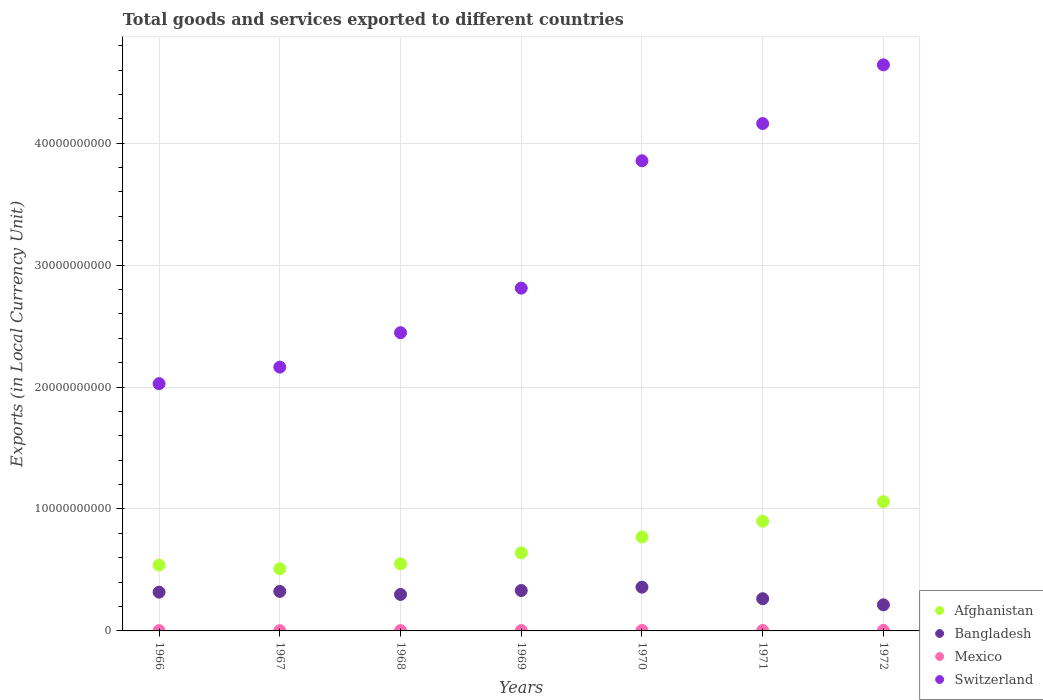How many different coloured dotlines are there?
Make the answer very short. 4. What is the Amount of goods and services exports in Afghanistan in 1971?
Keep it short and to the point. 9.00e+09. Across all years, what is the maximum Amount of goods and services exports in Switzerland?
Make the answer very short. 4.64e+1. Across all years, what is the minimum Amount of goods and services exports in Bangladesh?
Your answer should be very brief. 2.14e+09. In which year was the Amount of goods and services exports in Afghanistan maximum?
Offer a terse response. 1972. In which year was the Amount of goods and services exports in Afghanistan minimum?
Your answer should be compact. 1967. What is the total Amount of goods and services exports in Afghanistan in the graph?
Ensure brevity in your answer.  4.97e+1. What is the difference between the Amount of goods and services exports in Bangladesh in 1970 and that in 1971?
Ensure brevity in your answer.  9.45e+08. What is the difference between the Amount of goods and services exports in Bangladesh in 1969 and the Amount of goods and services exports in Mexico in 1970?
Your response must be concise. 3.28e+09. What is the average Amount of goods and services exports in Afghanistan per year?
Make the answer very short. 7.10e+09. In the year 1967, what is the difference between the Amount of goods and services exports in Switzerland and Amount of goods and services exports in Bangladesh?
Your answer should be very brief. 1.84e+1. What is the ratio of the Amount of goods and services exports in Mexico in 1967 to that in 1968?
Give a very brief answer. 0.88. What is the difference between the highest and the second highest Amount of goods and services exports in Switzerland?
Provide a succinct answer. 4.81e+09. What is the difference between the highest and the lowest Amount of goods and services exports in Afghanistan?
Make the answer very short. 5.50e+09. Is the sum of the Amount of goods and services exports in Bangladesh in 1968 and 1970 greater than the maximum Amount of goods and services exports in Mexico across all years?
Your answer should be very brief. Yes. Is it the case that in every year, the sum of the Amount of goods and services exports in Mexico and Amount of goods and services exports in Bangladesh  is greater than the sum of Amount of goods and services exports in Switzerland and Amount of goods and services exports in Afghanistan?
Give a very brief answer. No. Is the Amount of goods and services exports in Bangladesh strictly greater than the Amount of goods and services exports in Mexico over the years?
Your answer should be compact. Yes. How many dotlines are there?
Make the answer very short. 4. How many years are there in the graph?
Your response must be concise. 7. What is the difference between two consecutive major ticks on the Y-axis?
Give a very brief answer. 1.00e+1. Does the graph contain any zero values?
Your answer should be very brief. No. What is the title of the graph?
Give a very brief answer. Total goods and services exported to different countries. Does "Russian Federation" appear as one of the legend labels in the graph?
Ensure brevity in your answer.  No. What is the label or title of the Y-axis?
Your answer should be compact. Exports (in Local Currency Unit). What is the Exports (in Local Currency Unit) in Afghanistan in 1966?
Your answer should be very brief. 5.40e+09. What is the Exports (in Local Currency Unit) of Bangladesh in 1966?
Make the answer very short. 3.18e+09. What is the Exports (in Local Currency Unit) in Mexico in 1966?
Ensure brevity in your answer.  2.27e+07. What is the Exports (in Local Currency Unit) of Switzerland in 1966?
Offer a terse response. 2.03e+1. What is the Exports (in Local Currency Unit) of Afghanistan in 1967?
Offer a terse response. 5.10e+09. What is the Exports (in Local Currency Unit) in Bangladesh in 1967?
Ensure brevity in your answer.  3.24e+09. What is the Exports (in Local Currency Unit) of Mexico in 1967?
Offer a very short reply. 2.28e+07. What is the Exports (in Local Currency Unit) in Switzerland in 1967?
Offer a very short reply. 2.16e+1. What is the Exports (in Local Currency Unit) in Afghanistan in 1968?
Provide a succinct answer. 5.50e+09. What is the Exports (in Local Currency Unit) in Bangladesh in 1968?
Provide a succinct answer. 2.99e+09. What is the Exports (in Local Currency Unit) in Mexico in 1968?
Provide a short and direct response. 2.58e+07. What is the Exports (in Local Currency Unit) of Switzerland in 1968?
Provide a succinct answer. 2.45e+1. What is the Exports (in Local Currency Unit) in Afghanistan in 1969?
Keep it short and to the point. 6.40e+09. What is the Exports (in Local Currency Unit) of Bangladesh in 1969?
Give a very brief answer. 3.31e+09. What is the Exports (in Local Currency Unit) in Mexico in 1969?
Provide a succinct answer. 3.06e+07. What is the Exports (in Local Currency Unit) in Switzerland in 1969?
Make the answer very short. 2.81e+1. What is the Exports (in Local Currency Unit) in Afghanistan in 1970?
Make the answer very short. 7.70e+09. What is the Exports (in Local Currency Unit) in Bangladesh in 1970?
Provide a short and direct response. 3.59e+09. What is the Exports (in Local Currency Unit) of Mexico in 1970?
Your response must be concise. 3.44e+07. What is the Exports (in Local Currency Unit) of Switzerland in 1970?
Make the answer very short. 3.86e+1. What is the Exports (in Local Currency Unit) of Afghanistan in 1971?
Make the answer very short. 9.00e+09. What is the Exports (in Local Currency Unit) of Bangladesh in 1971?
Give a very brief answer. 2.64e+09. What is the Exports (in Local Currency Unit) of Mexico in 1971?
Ensure brevity in your answer.  3.74e+07. What is the Exports (in Local Currency Unit) in Switzerland in 1971?
Keep it short and to the point. 4.16e+1. What is the Exports (in Local Currency Unit) of Afghanistan in 1972?
Make the answer very short. 1.06e+1. What is the Exports (in Local Currency Unit) in Bangladesh in 1972?
Your answer should be compact. 2.14e+09. What is the Exports (in Local Currency Unit) of Mexico in 1972?
Keep it short and to the point. 4.55e+07. What is the Exports (in Local Currency Unit) in Switzerland in 1972?
Your answer should be compact. 4.64e+1. Across all years, what is the maximum Exports (in Local Currency Unit) in Afghanistan?
Provide a short and direct response. 1.06e+1. Across all years, what is the maximum Exports (in Local Currency Unit) of Bangladesh?
Offer a terse response. 3.59e+09. Across all years, what is the maximum Exports (in Local Currency Unit) in Mexico?
Your answer should be very brief. 4.55e+07. Across all years, what is the maximum Exports (in Local Currency Unit) in Switzerland?
Provide a short and direct response. 4.64e+1. Across all years, what is the minimum Exports (in Local Currency Unit) of Afghanistan?
Offer a very short reply. 5.10e+09. Across all years, what is the minimum Exports (in Local Currency Unit) of Bangladesh?
Offer a terse response. 2.14e+09. Across all years, what is the minimum Exports (in Local Currency Unit) of Mexico?
Make the answer very short. 2.27e+07. Across all years, what is the minimum Exports (in Local Currency Unit) of Switzerland?
Your response must be concise. 2.03e+1. What is the total Exports (in Local Currency Unit) of Afghanistan in the graph?
Your answer should be very brief. 4.97e+1. What is the total Exports (in Local Currency Unit) of Bangladesh in the graph?
Your response must be concise. 2.11e+1. What is the total Exports (in Local Currency Unit) in Mexico in the graph?
Provide a short and direct response. 2.19e+08. What is the total Exports (in Local Currency Unit) of Switzerland in the graph?
Make the answer very short. 2.21e+11. What is the difference between the Exports (in Local Currency Unit) of Afghanistan in 1966 and that in 1967?
Give a very brief answer. 3.00e+08. What is the difference between the Exports (in Local Currency Unit) of Bangladesh in 1966 and that in 1967?
Offer a terse response. -6.12e+07. What is the difference between the Exports (in Local Currency Unit) of Mexico in 1966 and that in 1967?
Your response must be concise. -8.90e+04. What is the difference between the Exports (in Local Currency Unit) of Switzerland in 1966 and that in 1967?
Provide a succinct answer. -1.36e+09. What is the difference between the Exports (in Local Currency Unit) of Afghanistan in 1966 and that in 1968?
Make the answer very short. -1.00e+08. What is the difference between the Exports (in Local Currency Unit) in Bangladesh in 1966 and that in 1968?
Your answer should be very brief. 1.86e+08. What is the difference between the Exports (in Local Currency Unit) in Mexico in 1966 and that in 1968?
Give a very brief answer. -3.12e+06. What is the difference between the Exports (in Local Currency Unit) of Switzerland in 1966 and that in 1968?
Keep it short and to the point. -4.18e+09. What is the difference between the Exports (in Local Currency Unit) in Afghanistan in 1966 and that in 1969?
Make the answer very short. -1.00e+09. What is the difference between the Exports (in Local Currency Unit) of Bangladesh in 1966 and that in 1969?
Make the answer very short. -1.33e+08. What is the difference between the Exports (in Local Currency Unit) of Mexico in 1966 and that in 1969?
Keep it short and to the point. -7.93e+06. What is the difference between the Exports (in Local Currency Unit) in Switzerland in 1966 and that in 1969?
Keep it short and to the point. -7.83e+09. What is the difference between the Exports (in Local Currency Unit) in Afghanistan in 1966 and that in 1970?
Make the answer very short. -2.30e+09. What is the difference between the Exports (in Local Currency Unit) of Bangladesh in 1966 and that in 1970?
Make the answer very short. -4.09e+08. What is the difference between the Exports (in Local Currency Unit) of Mexico in 1966 and that in 1970?
Your answer should be compact. -1.17e+07. What is the difference between the Exports (in Local Currency Unit) in Switzerland in 1966 and that in 1970?
Your answer should be compact. -1.83e+1. What is the difference between the Exports (in Local Currency Unit) of Afghanistan in 1966 and that in 1971?
Offer a terse response. -3.60e+09. What is the difference between the Exports (in Local Currency Unit) in Bangladesh in 1966 and that in 1971?
Your response must be concise. 5.36e+08. What is the difference between the Exports (in Local Currency Unit) of Mexico in 1966 and that in 1971?
Offer a terse response. -1.47e+07. What is the difference between the Exports (in Local Currency Unit) in Switzerland in 1966 and that in 1971?
Offer a very short reply. -2.13e+1. What is the difference between the Exports (in Local Currency Unit) in Afghanistan in 1966 and that in 1972?
Your response must be concise. -5.20e+09. What is the difference between the Exports (in Local Currency Unit) of Bangladesh in 1966 and that in 1972?
Ensure brevity in your answer.  1.04e+09. What is the difference between the Exports (in Local Currency Unit) of Mexico in 1966 and that in 1972?
Your answer should be compact. -2.28e+07. What is the difference between the Exports (in Local Currency Unit) of Switzerland in 1966 and that in 1972?
Ensure brevity in your answer.  -2.61e+1. What is the difference between the Exports (in Local Currency Unit) of Afghanistan in 1967 and that in 1968?
Provide a short and direct response. -4.00e+08. What is the difference between the Exports (in Local Currency Unit) in Bangladesh in 1967 and that in 1968?
Your answer should be very brief. 2.48e+08. What is the difference between the Exports (in Local Currency Unit) in Mexico in 1967 and that in 1968?
Ensure brevity in your answer.  -3.03e+06. What is the difference between the Exports (in Local Currency Unit) in Switzerland in 1967 and that in 1968?
Keep it short and to the point. -2.82e+09. What is the difference between the Exports (in Local Currency Unit) of Afghanistan in 1967 and that in 1969?
Your answer should be very brief. -1.30e+09. What is the difference between the Exports (in Local Currency Unit) in Bangladesh in 1967 and that in 1969?
Your answer should be compact. -7.21e+07. What is the difference between the Exports (in Local Currency Unit) in Mexico in 1967 and that in 1969?
Ensure brevity in your answer.  -7.84e+06. What is the difference between the Exports (in Local Currency Unit) in Switzerland in 1967 and that in 1969?
Your answer should be very brief. -6.48e+09. What is the difference between the Exports (in Local Currency Unit) of Afghanistan in 1967 and that in 1970?
Keep it short and to the point. -2.60e+09. What is the difference between the Exports (in Local Currency Unit) in Bangladesh in 1967 and that in 1970?
Provide a succinct answer. -3.48e+08. What is the difference between the Exports (in Local Currency Unit) in Mexico in 1967 and that in 1970?
Keep it short and to the point. -1.16e+07. What is the difference between the Exports (in Local Currency Unit) in Switzerland in 1967 and that in 1970?
Your response must be concise. -1.69e+1. What is the difference between the Exports (in Local Currency Unit) of Afghanistan in 1967 and that in 1971?
Offer a very short reply. -3.90e+09. What is the difference between the Exports (in Local Currency Unit) in Bangladesh in 1967 and that in 1971?
Your answer should be very brief. 5.97e+08. What is the difference between the Exports (in Local Currency Unit) in Mexico in 1967 and that in 1971?
Keep it short and to the point. -1.46e+07. What is the difference between the Exports (in Local Currency Unit) of Switzerland in 1967 and that in 1971?
Provide a succinct answer. -2.00e+1. What is the difference between the Exports (in Local Currency Unit) in Afghanistan in 1967 and that in 1972?
Your response must be concise. -5.50e+09. What is the difference between the Exports (in Local Currency Unit) in Bangladesh in 1967 and that in 1972?
Provide a short and direct response. 1.10e+09. What is the difference between the Exports (in Local Currency Unit) in Mexico in 1967 and that in 1972?
Keep it short and to the point. -2.27e+07. What is the difference between the Exports (in Local Currency Unit) of Switzerland in 1967 and that in 1972?
Offer a very short reply. -2.48e+1. What is the difference between the Exports (in Local Currency Unit) of Afghanistan in 1968 and that in 1969?
Provide a short and direct response. -9.00e+08. What is the difference between the Exports (in Local Currency Unit) of Bangladesh in 1968 and that in 1969?
Offer a terse response. -3.20e+08. What is the difference between the Exports (in Local Currency Unit) in Mexico in 1968 and that in 1969?
Offer a very short reply. -4.81e+06. What is the difference between the Exports (in Local Currency Unit) of Switzerland in 1968 and that in 1969?
Ensure brevity in your answer.  -3.65e+09. What is the difference between the Exports (in Local Currency Unit) in Afghanistan in 1968 and that in 1970?
Give a very brief answer. -2.20e+09. What is the difference between the Exports (in Local Currency Unit) of Bangladesh in 1968 and that in 1970?
Provide a short and direct response. -5.96e+08. What is the difference between the Exports (in Local Currency Unit) of Mexico in 1968 and that in 1970?
Keep it short and to the point. -8.60e+06. What is the difference between the Exports (in Local Currency Unit) of Switzerland in 1968 and that in 1970?
Provide a short and direct response. -1.41e+1. What is the difference between the Exports (in Local Currency Unit) in Afghanistan in 1968 and that in 1971?
Keep it short and to the point. -3.50e+09. What is the difference between the Exports (in Local Currency Unit) of Bangladesh in 1968 and that in 1971?
Make the answer very short. 3.50e+08. What is the difference between the Exports (in Local Currency Unit) of Mexico in 1968 and that in 1971?
Provide a succinct answer. -1.16e+07. What is the difference between the Exports (in Local Currency Unit) in Switzerland in 1968 and that in 1971?
Provide a short and direct response. -1.71e+1. What is the difference between the Exports (in Local Currency Unit) of Afghanistan in 1968 and that in 1972?
Your answer should be very brief. -5.10e+09. What is the difference between the Exports (in Local Currency Unit) in Bangladesh in 1968 and that in 1972?
Offer a very short reply. 8.52e+08. What is the difference between the Exports (in Local Currency Unit) in Mexico in 1968 and that in 1972?
Offer a very short reply. -1.97e+07. What is the difference between the Exports (in Local Currency Unit) in Switzerland in 1968 and that in 1972?
Make the answer very short. -2.20e+1. What is the difference between the Exports (in Local Currency Unit) in Afghanistan in 1969 and that in 1970?
Give a very brief answer. -1.30e+09. What is the difference between the Exports (in Local Currency Unit) in Bangladesh in 1969 and that in 1970?
Provide a succinct answer. -2.76e+08. What is the difference between the Exports (in Local Currency Unit) of Mexico in 1969 and that in 1970?
Your answer should be very brief. -3.79e+06. What is the difference between the Exports (in Local Currency Unit) in Switzerland in 1969 and that in 1970?
Ensure brevity in your answer.  -1.04e+1. What is the difference between the Exports (in Local Currency Unit) of Afghanistan in 1969 and that in 1971?
Give a very brief answer. -2.60e+09. What is the difference between the Exports (in Local Currency Unit) of Bangladesh in 1969 and that in 1971?
Your answer should be compact. 6.69e+08. What is the difference between the Exports (in Local Currency Unit) of Mexico in 1969 and that in 1971?
Give a very brief answer. -6.80e+06. What is the difference between the Exports (in Local Currency Unit) in Switzerland in 1969 and that in 1971?
Make the answer very short. -1.35e+1. What is the difference between the Exports (in Local Currency Unit) in Afghanistan in 1969 and that in 1972?
Your answer should be compact. -4.20e+09. What is the difference between the Exports (in Local Currency Unit) in Bangladesh in 1969 and that in 1972?
Keep it short and to the point. 1.17e+09. What is the difference between the Exports (in Local Currency Unit) of Mexico in 1969 and that in 1972?
Offer a very short reply. -1.49e+07. What is the difference between the Exports (in Local Currency Unit) of Switzerland in 1969 and that in 1972?
Give a very brief answer. -1.83e+1. What is the difference between the Exports (in Local Currency Unit) in Afghanistan in 1970 and that in 1971?
Provide a succinct answer. -1.30e+09. What is the difference between the Exports (in Local Currency Unit) of Bangladesh in 1970 and that in 1971?
Give a very brief answer. 9.45e+08. What is the difference between the Exports (in Local Currency Unit) of Mexico in 1970 and that in 1971?
Your response must be concise. -3.01e+06. What is the difference between the Exports (in Local Currency Unit) in Switzerland in 1970 and that in 1971?
Offer a very short reply. -3.05e+09. What is the difference between the Exports (in Local Currency Unit) in Afghanistan in 1970 and that in 1972?
Provide a succinct answer. -2.90e+09. What is the difference between the Exports (in Local Currency Unit) in Bangladesh in 1970 and that in 1972?
Your answer should be compact. 1.45e+09. What is the difference between the Exports (in Local Currency Unit) of Mexico in 1970 and that in 1972?
Your response must be concise. -1.11e+07. What is the difference between the Exports (in Local Currency Unit) in Switzerland in 1970 and that in 1972?
Keep it short and to the point. -7.86e+09. What is the difference between the Exports (in Local Currency Unit) of Afghanistan in 1971 and that in 1972?
Give a very brief answer. -1.60e+09. What is the difference between the Exports (in Local Currency Unit) in Bangladesh in 1971 and that in 1972?
Offer a terse response. 5.02e+08. What is the difference between the Exports (in Local Currency Unit) of Mexico in 1971 and that in 1972?
Ensure brevity in your answer.  -8.10e+06. What is the difference between the Exports (in Local Currency Unit) in Switzerland in 1971 and that in 1972?
Offer a terse response. -4.81e+09. What is the difference between the Exports (in Local Currency Unit) of Afghanistan in 1966 and the Exports (in Local Currency Unit) of Bangladesh in 1967?
Your response must be concise. 2.16e+09. What is the difference between the Exports (in Local Currency Unit) in Afghanistan in 1966 and the Exports (in Local Currency Unit) in Mexico in 1967?
Ensure brevity in your answer.  5.38e+09. What is the difference between the Exports (in Local Currency Unit) of Afghanistan in 1966 and the Exports (in Local Currency Unit) of Switzerland in 1967?
Your response must be concise. -1.62e+1. What is the difference between the Exports (in Local Currency Unit) of Bangladesh in 1966 and the Exports (in Local Currency Unit) of Mexico in 1967?
Provide a short and direct response. 3.16e+09. What is the difference between the Exports (in Local Currency Unit) in Bangladesh in 1966 and the Exports (in Local Currency Unit) in Switzerland in 1967?
Give a very brief answer. -1.85e+1. What is the difference between the Exports (in Local Currency Unit) of Mexico in 1966 and the Exports (in Local Currency Unit) of Switzerland in 1967?
Provide a short and direct response. -2.16e+1. What is the difference between the Exports (in Local Currency Unit) in Afghanistan in 1966 and the Exports (in Local Currency Unit) in Bangladesh in 1968?
Your answer should be very brief. 2.41e+09. What is the difference between the Exports (in Local Currency Unit) in Afghanistan in 1966 and the Exports (in Local Currency Unit) in Mexico in 1968?
Offer a very short reply. 5.37e+09. What is the difference between the Exports (in Local Currency Unit) of Afghanistan in 1966 and the Exports (in Local Currency Unit) of Switzerland in 1968?
Your response must be concise. -1.91e+1. What is the difference between the Exports (in Local Currency Unit) of Bangladesh in 1966 and the Exports (in Local Currency Unit) of Mexico in 1968?
Give a very brief answer. 3.15e+09. What is the difference between the Exports (in Local Currency Unit) of Bangladesh in 1966 and the Exports (in Local Currency Unit) of Switzerland in 1968?
Keep it short and to the point. -2.13e+1. What is the difference between the Exports (in Local Currency Unit) in Mexico in 1966 and the Exports (in Local Currency Unit) in Switzerland in 1968?
Keep it short and to the point. -2.44e+1. What is the difference between the Exports (in Local Currency Unit) of Afghanistan in 1966 and the Exports (in Local Currency Unit) of Bangladesh in 1969?
Your answer should be very brief. 2.09e+09. What is the difference between the Exports (in Local Currency Unit) in Afghanistan in 1966 and the Exports (in Local Currency Unit) in Mexico in 1969?
Provide a short and direct response. 5.37e+09. What is the difference between the Exports (in Local Currency Unit) of Afghanistan in 1966 and the Exports (in Local Currency Unit) of Switzerland in 1969?
Ensure brevity in your answer.  -2.27e+1. What is the difference between the Exports (in Local Currency Unit) of Bangladesh in 1966 and the Exports (in Local Currency Unit) of Mexico in 1969?
Your answer should be very brief. 3.15e+09. What is the difference between the Exports (in Local Currency Unit) of Bangladesh in 1966 and the Exports (in Local Currency Unit) of Switzerland in 1969?
Your answer should be very brief. -2.49e+1. What is the difference between the Exports (in Local Currency Unit) in Mexico in 1966 and the Exports (in Local Currency Unit) in Switzerland in 1969?
Your answer should be compact. -2.81e+1. What is the difference between the Exports (in Local Currency Unit) in Afghanistan in 1966 and the Exports (in Local Currency Unit) in Bangladesh in 1970?
Give a very brief answer. 1.81e+09. What is the difference between the Exports (in Local Currency Unit) in Afghanistan in 1966 and the Exports (in Local Currency Unit) in Mexico in 1970?
Your answer should be very brief. 5.37e+09. What is the difference between the Exports (in Local Currency Unit) of Afghanistan in 1966 and the Exports (in Local Currency Unit) of Switzerland in 1970?
Your answer should be compact. -3.32e+1. What is the difference between the Exports (in Local Currency Unit) in Bangladesh in 1966 and the Exports (in Local Currency Unit) in Mexico in 1970?
Offer a very short reply. 3.14e+09. What is the difference between the Exports (in Local Currency Unit) in Bangladesh in 1966 and the Exports (in Local Currency Unit) in Switzerland in 1970?
Offer a terse response. -3.54e+1. What is the difference between the Exports (in Local Currency Unit) in Mexico in 1966 and the Exports (in Local Currency Unit) in Switzerland in 1970?
Make the answer very short. -3.85e+1. What is the difference between the Exports (in Local Currency Unit) of Afghanistan in 1966 and the Exports (in Local Currency Unit) of Bangladesh in 1971?
Provide a short and direct response. 2.76e+09. What is the difference between the Exports (in Local Currency Unit) in Afghanistan in 1966 and the Exports (in Local Currency Unit) in Mexico in 1971?
Keep it short and to the point. 5.36e+09. What is the difference between the Exports (in Local Currency Unit) of Afghanistan in 1966 and the Exports (in Local Currency Unit) of Switzerland in 1971?
Your answer should be compact. -3.62e+1. What is the difference between the Exports (in Local Currency Unit) in Bangladesh in 1966 and the Exports (in Local Currency Unit) in Mexico in 1971?
Offer a very short reply. 3.14e+09. What is the difference between the Exports (in Local Currency Unit) in Bangladesh in 1966 and the Exports (in Local Currency Unit) in Switzerland in 1971?
Offer a very short reply. -3.84e+1. What is the difference between the Exports (in Local Currency Unit) of Mexico in 1966 and the Exports (in Local Currency Unit) of Switzerland in 1971?
Ensure brevity in your answer.  -4.16e+1. What is the difference between the Exports (in Local Currency Unit) of Afghanistan in 1966 and the Exports (in Local Currency Unit) of Bangladesh in 1972?
Your response must be concise. 3.26e+09. What is the difference between the Exports (in Local Currency Unit) of Afghanistan in 1966 and the Exports (in Local Currency Unit) of Mexico in 1972?
Your answer should be compact. 5.35e+09. What is the difference between the Exports (in Local Currency Unit) in Afghanistan in 1966 and the Exports (in Local Currency Unit) in Switzerland in 1972?
Make the answer very short. -4.10e+1. What is the difference between the Exports (in Local Currency Unit) in Bangladesh in 1966 and the Exports (in Local Currency Unit) in Mexico in 1972?
Your response must be concise. 3.13e+09. What is the difference between the Exports (in Local Currency Unit) of Bangladesh in 1966 and the Exports (in Local Currency Unit) of Switzerland in 1972?
Your answer should be very brief. -4.32e+1. What is the difference between the Exports (in Local Currency Unit) of Mexico in 1966 and the Exports (in Local Currency Unit) of Switzerland in 1972?
Offer a terse response. -4.64e+1. What is the difference between the Exports (in Local Currency Unit) of Afghanistan in 1967 and the Exports (in Local Currency Unit) of Bangladesh in 1968?
Offer a very short reply. 2.11e+09. What is the difference between the Exports (in Local Currency Unit) of Afghanistan in 1967 and the Exports (in Local Currency Unit) of Mexico in 1968?
Give a very brief answer. 5.07e+09. What is the difference between the Exports (in Local Currency Unit) of Afghanistan in 1967 and the Exports (in Local Currency Unit) of Switzerland in 1968?
Provide a short and direct response. -1.94e+1. What is the difference between the Exports (in Local Currency Unit) of Bangladesh in 1967 and the Exports (in Local Currency Unit) of Mexico in 1968?
Provide a succinct answer. 3.21e+09. What is the difference between the Exports (in Local Currency Unit) of Bangladesh in 1967 and the Exports (in Local Currency Unit) of Switzerland in 1968?
Provide a succinct answer. -2.12e+1. What is the difference between the Exports (in Local Currency Unit) of Mexico in 1967 and the Exports (in Local Currency Unit) of Switzerland in 1968?
Your response must be concise. -2.44e+1. What is the difference between the Exports (in Local Currency Unit) of Afghanistan in 1967 and the Exports (in Local Currency Unit) of Bangladesh in 1969?
Your response must be concise. 1.79e+09. What is the difference between the Exports (in Local Currency Unit) of Afghanistan in 1967 and the Exports (in Local Currency Unit) of Mexico in 1969?
Offer a very short reply. 5.07e+09. What is the difference between the Exports (in Local Currency Unit) in Afghanistan in 1967 and the Exports (in Local Currency Unit) in Switzerland in 1969?
Offer a very short reply. -2.30e+1. What is the difference between the Exports (in Local Currency Unit) in Bangladesh in 1967 and the Exports (in Local Currency Unit) in Mexico in 1969?
Give a very brief answer. 3.21e+09. What is the difference between the Exports (in Local Currency Unit) of Bangladesh in 1967 and the Exports (in Local Currency Unit) of Switzerland in 1969?
Ensure brevity in your answer.  -2.49e+1. What is the difference between the Exports (in Local Currency Unit) of Mexico in 1967 and the Exports (in Local Currency Unit) of Switzerland in 1969?
Offer a very short reply. -2.81e+1. What is the difference between the Exports (in Local Currency Unit) of Afghanistan in 1967 and the Exports (in Local Currency Unit) of Bangladesh in 1970?
Your response must be concise. 1.51e+09. What is the difference between the Exports (in Local Currency Unit) of Afghanistan in 1967 and the Exports (in Local Currency Unit) of Mexico in 1970?
Your answer should be compact. 5.07e+09. What is the difference between the Exports (in Local Currency Unit) in Afghanistan in 1967 and the Exports (in Local Currency Unit) in Switzerland in 1970?
Provide a short and direct response. -3.35e+1. What is the difference between the Exports (in Local Currency Unit) in Bangladesh in 1967 and the Exports (in Local Currency Unit) in Mexico in 1970?
Your answer should be compact. 3.21e+09. What is the difference between the Exports (in Local Currency Unit) of Bangladesh in 1967 and the Exports (in Local Currency Unit) of Switzerland in 1970?
Provide a short and direct response. -3.53e+1. What is the difference between the Exports (in Local Currency Unit) in Mexico in 1967 and the Exports (in Local Currency Unit) in Switzerland in 1970?
Ensure brevity in your answer.  -3.85e+1. What is the difference between the Exports (in Local Currency Unit) in Afghanistan in 1967 and the Exports (in Local Currency Unit) in Bangladesh in 1971?
Offer a very short reply. 2.46e+09. What is the difference between the Exports (in Local Currency Unit) of Afghanistan in 1967 and the Exports (in Local Currency Unit) of Mexico in 1971?
Your response must be concise. 5.06e+09. What is the difference between the Exports (in Local Currency Unit) in Afghanistan in 1967 and the Exports (in Local Currency Unit) in Switzerland in 1971?
Your answer should be very brief. -3.65e+1. What is the difference between the Exports (in Local Currency Unit) of Bangladesh in 1967 and the Exports (in Local Currency Unit) of Mexico in 1971?
Your response must be concise. 3.20e+09. What is the difference between the Exports (in Local Currency Unit) of Bangladesh in 1967 and the Exports (in Local Currency Unit) of Switzerland in 1971?
Keep it short and to the point. -3.84e+1. What is the difference between the Exports (in Local Currency Unit) in Mexico in 1967 and the Exports (in Local Currency Unit) in Switzerland in 1971?
Provide a succinct answer. -4.16e+1. What is the difference between the Exports (in Local Currency Unit) in Afghanistan in 1967 and the Exports (in Local Currency Unit) in Bangladesh in 1972?
Your response must be concise. 2.96e+09. What is the difference between the Exports (in Local Currency Unit) of Afghanistan in 1967 and the Exports (in Local Currency Unit) of Mexico in 1972?
Your answer should be very brief. 5.05e+09. What is the difference between the Exports (in Local Currency Unit) of Afghanistan in 1967 and the Exports (in Local Currency Unit) of Switzerland in 1972?
Your answer should be compact. -4.13e+1. What is the difference between the Exports (in Local Currency Unit) in Bangladesh in 1967 and the Exports (in Local Currency Unit) in Mexico in 1972?
Ensure brevity in your answer.  3.19e+09. What is the difference between the Exports (in Local Currency Unit) in Bangladesh in 1967 and the Exports (in Local Currency Unit) in Switzerland in 1972?
Your answer should be very brief. -4.32e+1. What is the difference between the Exports (in Local Currency Unit) in Mexico in 1967 and the Exports (in Local Currency Unit) in Switzerland in 1972?
Ensure brevity in your answer.  -4.64e+1. What is the difference between the Exports (in Local Currency Unit) in Afghanistan in 1968 and the Exports (in Local Currency Unit) in Bangladesh in 1969?
Offer a very short reply. 2.19e+09. What is the difference between the Exports (in Local Currency Unit) of Afghanistan in 1968 and the Exports (in Local Currency Unit) of Mexico in 1969?
Provide a short and direct response. 5.47e+09. What is the difference between the Exports (in Local Currency Unit) in Afghanistan in 1968 and the Exports (in Local Currency Unit) in Switzerland in 1969?
Your answer should be very brief. -2.26e+1. What is the difference between the Exports (in Local Currency Unit) in Bangladesh in 1968 and the Exports (in Local Currency Unit) in Mexico in 1969?
Keep it short and to the point. 2.96e+09. What is the difference between the Exports (in Local Currency Unit) in Bangladesh in 1968 and the Exports (in Local Currency Unit) in Switzerland in 1969?
Provide a succinct answer. -2.51e+1. What is the difference between the Exports (in Local Currency Unit) of Mexico in 1968 and the Exports (in Local Currency Unit) of Switzerland in 1969?
Your response must be concise. -2.81e+1. What is the difference between the Exports (in Local Currency Unit) of Afghanistan in 1968 and the Exports (in Local Currency Unit) of Bangladesh in 1970?
Your answer should be very brief. 1.91e+09. What is the difference between the Exports (in Local Currency Unit) of Afghanistan in 1968 and the Exports (in Local Currency Unit) of Mexico in 1970?
Provide a short and direct response. 5.47e+09. What is the difference between the Exports (in Local Currency Unit) in Afghanistan in 1968 and the Exports (in Local Currency Unit) in Switzerland in 1970?
Your answer should be compact. -3.31e+1. What is the difference between the Exports (in Local Currency Unit) in Bangladesh in 1968 and the Exports (in Local Currency Unit) in Mexico in 1970?
Your answer should be compact. 2.96e+09. What is the difference between the Exports (in Local Currency Unit) of Bangladesh in 1968 and the Exports (in Local Currency Unit) of Switzerland in 1970?
Keep it short and to the point. -3.56e+1. What is the difference between the Exports (in Local Currency Unit) of Mexico in 1968 and the Exports (in Local Currency Unit) of Switzerland in 1970?
Ensure brevity in your answer.  -3.85e+1. What is the difference between the Exports (in Local Currency Unit) in Afghanistan in 1968 and the Exports (in Local Currency Unit) in Bangladesh in 1971?
Offer a terse response. 2.86e+09. What is the difference between the Exports (in Local Currency Unit) in Afghanistan in 1968 and the Exports (in Local Currency Unit) in Mexico in 1971?
Offer a terse response. 5.46e+09. What is the difference between the Exports (in Local Currency Unit) of Afghanistan in 1968 and the Exports (in Local Currency Unit) of Switzerland in 1971?
Your response must be concise. -3.61e+1. What is the difference between the Exports (in Local Currency Unit) of Bangladesh in 1968 and the Exports (in Local Currency Unit) of Mexico in 1971?
Keep it short and to the point. 2.96e+09. What is the difference between the Exports (in Local Currency Unit) of Bangladesh in 1968 and the Exports (in Local Currency Unit) of Switzerland in 1971?
Provide a short and direct response. -3.86e+1. What is the difference between the Exports (in Local Currency Unit) in Mexico in 1968 and the Exports (in Local Currency Unit) in Switzerland in 1971?
Make the answer very short. -4.16e+1. What is the difference between the Exports (in Local Currency Unit) of Afghanistan in 1968 and the Exports (in Local Currency Unit) of Bangladesh in 1972?
Your answer should be compact. 3.36e+09. What is the difference between the Exports (in Local Currency Unit) in Afghanistan in 1968 and the Exports (in Local Currency Unit) in Mexico in 1972?
Offer a terse response. 5.45e+09. What is the difference between the Exports (in Local Currency Unit) in Afghanistan in 1968 and the Exports (in Local Currency Unit) in Switzerland in 1972?
Offer a terse response. -4.09e+1. What is the difference between the Exports (in Local Currency Unit) in Bangladesh in 1968 and the Exports (in Local Currency Unit) in Mexico in 1972?
Your answer should be very brief. 2.95e+09. What is the difference between the Exports (in Local Currency Unit) of Bangladesh in 1968 and the Exports (in Local Currency Unit) of Switzerland in 1972?
Provide a short and direct response. -4.34e+1. What is the difference between the Exports (in Local Currency Unit) of Mexico in 1968 and the Exports (in Local Currency Unit) of Switzerland in 1972?
Offer a terse response. -4.64e+1. What is the difference between the Exports (in Local Currency Unit) in Afghanistan in 1969 and the Exports (in Local Currency Unit) in Bangladesh in 1970?
Your answer should be very brief. 2.81e+09. What is the difference between the Exports (in Local Currency Unit) of Afghanistan in 1969 and the Exports (in Local Currency Unit) of Mexico in 1970?
Provide a succinct answer. 6.37e+09. What is the difference between the Exports (in Local Currency Unit) in Afghanistan in 1969 and the Exports (in Local Currency Unit) in Switzerland in 1970?
Give a very brief answer. -3.22e+1. What is the difference between the Exports (in Local Currency Unit) in Bangladesh in 1969 and the Exports (in Local Currency Unit) in Mexico in 1970?
Give a very brief answer. 3.28e+09. What is the difference between the Exports (in Local Currency Unit) in Bangladesh in 1969 and the Exports (in Local Currency Unit) in Switzerland in 1970?
Give a very brief answer. -3.52e+1. What is the difference between the Exports (in Local Currency Unit) of Mexico in 1969 and the Exports (in Local Currency Unit) of Switzerland in 1970?
Provide a short and direct response. -3.85e+1. What is the difference between the Exports (in Local Currency Unit) of Afghanistan in 1969 and the Exports (in Local Currency Unit) of Bangladesh in 1971?
Your answer should be very brief. 3.76e+09. What is the difference between the Exports (in Local Currency Unit) in Afghanistan in 1969 and the Exports (in Local Currency Unit) in Mexico in 1971?
Offer a terse response. 6.36e+09. What is the difference between the Exports (in Local Currency Unit) of Afghanistan in 1969 and the Exports (in Local Currency Unit) of Switzerland in 1971?
Provide a succinct answer. -3.52e+1. What is the difference between the Exports (in Local Currency Unit) of Bangladesh in 1969 and the Exports (in Local Currency Unit) of Mexico in 1971?
Offer a very short reply. 3.27e+09. What is the difference between the Exports (in Local Currency Unit) of Bangladesh in 1969 and the Exports (in Local Currency Unit) of Switzerland in 1971?
Provide a succinct answer. -3.83e+1. What is the difference between the Exports (in Local Currency Unit) in Mexico in 1969 and the Exports (in Local Currency Unit) in Switzerland in 1971?
Your response must be concise. -4.16e+1. What is the difference between the Exports (in Local Currency Unit) of Afghanistan in 1969 and the Exports (in Local Currency Unit) of Bangladesh in 1972?
Provide a succinct answer. 4.26e+09. What is the difference between the Exports (in Local Currency Unit) in Afghanistan in 1969 and the Exports (in Local Currency Unit) in Mexico in 1972?
Offer a terse response. 6.35e+09. What is the difference between the Exports (in Local Currency Unit) of Afghanistan in 1969 and the Exports (in Local Currency Unit) of Switzerland in 1972?
Your answer should be compact. -4.00e+1. What is the difference between the Exports (in Local Currency Unit) in Bangladesh in 1969 and the Exports (in Local Currency Unit) in Mexico in 1972?
Give a very brief answer. 3.27e+09. What is the difference between the Exports (in Local Currency Unit) of Bangladesh in 1969 and the Exports (in Local Currency Unit) of Switzerland in 1972?
Your answer should be very brief. -4.31e+1. What is the difference between the Exports (in Local Currency Unit) in Mexico in 1969 and the Exports (in Local Currency Unit) in Switzerland in 1972?
Keep it short and to the point. -4.64e+1. What is the difference between the Exports (in Local Currency Unit) in Afghanistan in 1970 and the Exports (in Local Currency Unit) in Bangladesh in 1971?
Your answer should be compact. 5.06e+09. What is the difference between the Exports (in Local Currency Unit) of Afghanistan in 1970 and the Exports (in Local Currency Unit) of Mexico in 1971?
Your answer should be very brief. 7.66e+09. What is the difference between the Exports (in Local Currency Unit) of Afghanistan in 1970 and the Exports (in Local Currency Unit) of Switzerland in 1971?
Provide a succinct answer. -3.39e+1. What is the difference between the Exports (in Local Currency Unit) of Bangladesh in 1970 and the Exports (in Local Currency Unit) of Mexico in 1971?
Keep it short and to the point. 3.55e+09. What is the difference between the Exports (in Local Currency Unit) of Bangladesh in 1970 and the Exports (in Local Currency Unit) of Switzerland in 1971?
Offer a very short reply. -3.80e+1. What is the difference between the Exports (in Local Currency Unit) in Mexico in 1970 and the Exports (in Local Currency Unit) in Switzerland in 1971?
Your answer should be compact. -4.16e+1. What is the difference between the Exports (in Local Currency Unit) of Afghanistan in 1970 and the Exports (in Local Currency Unit) of Bangladesh in 1972?
Make the answer very short. 5.56e+09. What is the difference between the Exports (in Local Currency Unit) of Afghanistan in 1970 and the Exports (in Local Currency Unit) of Mexico in 1972?
Your answer should be compact. 7.65e+09. What is the difference between the Exports (in Local Currency Unit) in Afghanistan in 1970 and the Exports (in Local Currency Unit) in Switzerland in 1972?
Ensure brevity in your answer.  -3.87e+1. What is the difference between the Exports (in Local Currency Unit) of Bangladesh in 1970 and the Exports (in Local Currency Unit) of Mexico in 1972?
Give a very brief answer. 3.54e+09. What is the difference between the Exports (in Local Currency Unit) in Bangladesh in 1970 and the Exports (in Local Currency Unit) in Switzerland in 1972?
Keep it short and to the point. -4.28e+1. What is the difference between the Exports (in Local Currency Unit) of Mexico in 1970 and the Exports (in Local Currency Unit) of Switzerland in 1972?
Your answer should be compact. -4.64e+1. What is the difference between the Exports (in Local Currency Unit) in Afghanistan in 1971 and the Exports (in Local Currency Unit) in Bangladesh in 1972?
Offer a very short reply. 6.86e+09. What is the difference between the Exports (in Local Currency Unit) in Afghanistan in 1971 and the Exports (in Local Currency Unit) in Mexico in 1972?
Your answer should be very brief. 8.95e+09. What is the difference between the Exports (in Local Currency Unit) in Afghanistan in 1971 and the Exports (in Local Currency Unit) in Switzerland in 1972?
Give a very brief answer. -3.74e+1. What is the difference between the Exports (in Local Currency Unit) of Bangladesh in 1971 and the Exports (in Local Currency Unit) of Mexico in 1972?
Provide a succinct answer. 2.60e+09. What is the difference between the Exports (in Local Currency Unit) in Bangladesh in 1971 and the Exports (in Local Currency Unit) in Switzerland in 1972?
Your response must be concise. -4.38e+1. What is the difference between the Exports (in Local Currency Unit) of Mexico in 1971 and the Exports (in Local Currency Unit) of Switzerland in 1972?
Provide a succinct answer. -4.64e+1. What is the average Exports (in Local Currency Unit) of Afghanistan per year?
Offer a very short reply. 7.10e+09. What is the average Exports (in Local Currency Unit) in Bangladesh per year?
Your response must be concise. 3.01e+09. What is the average Exports (in Local Currency Unit) of Mexico per year?
Your answer should be very brief. 3.13e+07. What is the average Exports (in Local Currency Unit) in Switzerland per year?
Your response must be concise. 3.16e+1. In the year 1966, what is the difference between the Exports (in Local Currency Unit) of Afghanistan and Exports (in Local Currency Unit) of Bangladesh?
Your answer should be compact. 2.22e+09. In the year 1966, what is the difference between the Exports (in Local Currency Unit) of Afghanistan and Exports (in Local Currency Unit) of Mexico?
Provide a succinct answer. 5.38e+09. In the year 1966, what is the difference between the Exports (in Local Currency Unit) of Afghanistan and Exports (in Local Currency Unit) of Switzerland?
Ensure brevity in your answer.  -1.49e+1. In the year 1966, what is the difference between the Exports (in Local Currency Unit) of Bangladesh and Exports (in Local Currency Unit) of Mexico?
Your answer should be very brief. 3.16e+09. In the year 1966, what is the difference between the Exports (in Local Currency Unit) in Bangladesh and Exports (in Local Currency Unit) in Switzerland?
Make the answer very short. -1.71e+1. In the year 1966, what is the difference between the Exports (in Local Currency Unit) in Mexico and Exports (in Local Currency Unit) in Switzerland?
Ensure brevity in your answer.  -2.03e+1. In the year 1967, what is the difference between the Exports (in Local Currency Unit) of Afghanistan and Exports (in Local Currency Unit) of Bangladesh?
Make the answer very short. 1.86e+09. In the year 1967, what is the difference between the Exports (in Local Currency Unit) in Afghanistan and Exports (in Local Currency Unit) in Mexico?
Offer a very short reply. 5.08e+09. In the year 1967, what is the difference between the Exports (in Local Currency Unit) in Afghanistan and Exports (in Local Currency Unit) in Switzerland?
Ensure brevity in your answer.  -1.65e+1. In the year 1967, what is the difference between the Exports (in Local Currency Unit) of Bangladesh and Exports (in Local Currency Unit) of Mexico?
Offer a terse response. 3.22e+09. In the year 1967, what is the difference between the Exports (in Local Currency Unit) in Bangladesh and Exports (in Local Currency Unit) in Switzerland?
Provide a succinct answer. -1.84e+1. In the year 1967, what is the difference between the Exports (in Local Currency Unit) in Mexico and Exports (in Local Currency Unit) in Switzerland?
Give a very brief answer. -2.16e+1. In the year 1968, what is the difference between the Exports (in Local Currency Unit) of Afghanistan and Exports (in Local Currency Unit) of Bangladesh?
Make the answer very short. 2.51e+09. In the year 1968, what is the difference between the Exports (in Local Currency Unit) in Afghanistan and Exports (in Local Currency Unit) in Mexico?
Your answer should be very brief. 5.47e+09. In the year 1968, what is the difference between the Exports (in Local Currency Unit) of Afghanistan and Exports (in Local Currency Unit) of Switzerland?
Ensure brevity in your answer.  -1.90e+1. In the year 1968, what is the difference between the Exports (in Local Currency Unit) in Bangladesh and Exports (in Local Currency Unit) in Mexico?
Your response must be concise. 2.97e+09. In the year 1968, what is the difference between the Exports (in Local Currency Unit) of Bangladesh and Exports (in Local Currency Unit) of Switzerland?
Your answer should be compact. -2.15e+1. In the year 1968, what is the difference between the Exports (in Local Currency Unit) of Mexico and Exports (in Local Currency Unit) of Switzerland?
Offer a terse response. -2.44e+1. In the year 1969, what is the difference between the Exports (in Local Currency Unit) in Afghanistan and Exports (in Local Currency Unit) in Bangladesh?
Provide a short and direct response. 3.09e+09. In the year 1969, what is the difference between the Exports (in Local Currency Unit) of Afghanistan and Exports (in Local Currency Unit) of Mexico?
Provide a succinct answer. 6.37e+09. In the year 1969, what is the difference between the Exports (in Local Currency Unit) of Afghanistan and Exports (in Local Currency Unit) of Switzerland?
Provide a succinct answer. -2.17e+1. In the year 1969, what is the difference between the Exports (in Local Currency Unit) in Bangladesh and Exports (in Local Currency Unit) in Mexico?
Your answer should be compact. 3.28e+09. In the year 1969, what is the difference between the Exports (in Local Currency Unit) in Bangladesh and Exports (in Local Currency Unit) in Switzerland?
Your response must be concise. -2.48e+1. In the year 1969, what is the difference between the Exports (in Local Currency Unit) in Mexico and Exports (in Local Currency Unit) in Switzerland?
Ensure brevity in your answer.  -2.81e+1. In the year 1970, what is the difference between the Exports (in Local Currency Unit) of Afghanistan and Exports (in Local Currency Unit) of Bangladesh?
Keep it short and to the point. 4.11e+09. In the year 1970, what is the difference between the Exports (in Local Currency Unit) of Afghanistan and Exports (in Local Currency Unit) of Mexico?
Provide a succinct answer. 7.67e+09. In the year 1970, what is the difference between the Exports (in Local Currency Unit) in Afghanistan and Exports (in Local Currency Unit) in Switzerland?
Ensure brevity in your answer.  -3.09e+1. In the year 1970, what is the difference between the Exports (in Local Currency Unit) in Bangladesh and Exports (in Local Currency Unit) in Mexico?
Offer a very short reply. 3.55e+09. In the year 1970, what is the difference between the Exports (in Local Currency Unit) of Bangladesh and Exports (in Local Currency Unit) of Switzerland?
Provide a short and direct response. -3.50e+1. In the year 1970, what is the difference between the Exports (in Local Currency Unit) in Mexico and Exports (in Local Currency Unit) in Switzerland?
Provide a short and direct response. -3.85e+1. In the year 1971, what is the difference between the Exports (in Local Currency Unit) in Afghanistan and Exports (in Local Currency Unit) in Bangladesh?
Make the answer very short. 6.36e+09. In the year 1971, what is the difference between the Exports (in Local Currency Unit) of Afghanistan and Exports (in Local Currency Unit) of Mexico?
Make the answer very short. 8.96e+09. In the year 1971, what is the difference between the Exports (in Local Currency Unit) of Afghanistan and Exports (in Local Currency Unit) of Switzerland?
Provide a short and direct response. -3.26e+1. In the year 1971, what is the difference between the Exports (in Local Currency Unit) in Bangladesh and Exports (in Local Currency Unit) in Mexico?
Your answer should be compact. 2.61e+09. In the year 1971, what is the difference between the Exports (in Local Currency Unit) of Bangladesh and Exports (in Local Currency Unit) of Switzerland?
Make the answer very short. -3.90e+1. In the year 1971, what is the difference between the Exports (in Local Currency Unit) in Mexico and Exports (in Local Currency Unit) in Switzerland?
Keep it short and to the point. -4.16e+1. In the year 1972, what is the difference between the Exports (in Local Currency Unit) in Afghanistan and Exports (in Local Currency Unit) in Bangladesh?
Your answer should be very brief. 8.46e+09. In the year 1972, what is the difference between the Exports (in Local Currency Unit) of Afghanistan and Exports (in Local Currency Unit) of Mexico?
Ensure brevity in your answer.  1.06e+1. In the year 1972, what is the difference between the Exports (in Local Currency Unit) of Afghanistan and Exports (in Local Currency Unit) of Switzerland?
Offer a very short reply. -3.58e+1. In the year 1972, what is the difference between the Exports (in Local Currency Unit) of Bangladesh and Exports (in Local Currency Unit) of Mexico?
Make the answer very short. 2.10e+09. In the year 1972, what is the difference between the Exports (in Local Currency Unit) in Bangladesh and Exports (in Local Currency Unit) in Switzerland?
Your answer should be compact. -4.43e+1. In the year 1972, what is the difference between the Exports (in Local Currency Unit) of Mexico and Exports (in Local Currency Unit) of Switzerland?
Keep it short and to the point. -4.64e+1. What is the ratio of the Exports (in Local Currency Unit) of Afghanistan in 1966 to that in 1967?
Your answer should be very brief. 1.06. What is the ratio of the Exports (in Local Currency Unit) in Bangladesh in 1966 to that in 1967?
Your answer should be very brief. 0.98. What is the ratio of the Exports (in Local Currency Unit) of Switzerland in 1966 to that in 1967?
Provide a succinct answer. 0.94. What is the ratio of the Exports (in Local Currency Unit) of Afghanistan in 1966 to that in 1968?
Your answer should be compact. 0.98. What is the ratio of the Exports (in Local Currency Unit) of Bangladesh in 1966 to that in 1968?
Offer a terse response. 1.06. What is the ratio of the Exports (in Local Currency Unit) of Mexico in 1966 to that in 1968?
Offer a very short reply. 0.88. What is the ratio of the Exports (in Local Currency Unit) of Switzerland in 1966 to that in 1968?
Your answer should be compact. 0.83. What is the ratio of the Exports (in Local Currency Unit) of Afghanistan in 1966 to that in 1969?
Offer a very short reply. 0.84. What is the ratio of the Exports (in Local Currency Unit) in Bangladesh in 1966 to that in 1969?
Your answer should be very brief. 0.96. What is the ratio of the Exports (in Local Currency Unit) in Mexico in 1966 to that in 1969?
Make the answer very short. 0.74. What is the ratio of the Exports (in Local Currency Unit) in Switzerland in 1966 to that in 1969?
Ensure brevity in your answer.  0.72. What is the ratio of the Exports (in Local Currency Unit) of Afghanistan in 1966 to that in 1970?
Offer a terse response. 0.7. What is the ratio of the Exports (in Local Currency Unit) in Bangladesh in 1966 to that in 1970?
Give a very brief answer. 0.89. What is the ratio of the Exports (in Local Currency Unit) of Mexico in 1966 to that in 1970?
Offer a terse response. 0.66. What is the ratio of the Exports (in Local Currency Unit) in Switzerland in 1966 to that in 1970?
Ensure brevity in your answer.  0.53. What is the ratio of the Exports (in Local Currency Unit) in Afghanistan in 1966 to that in 1971?
Provide a succinct answer. 0.6. What is the ratio of the Exports (in Local Currency Unit) of Bangladesh in 1966 to that in 1971?
Ensure brevity in your answer.  1.2. What is the ratio of the Exports (in Local Currency Unit) in Mexico in 1966 to that in 1971?
Offer a terse response. 0.61. What is the ratio of the Exports (in Local Currency Unit) of Switzerland in 1966 to that in 1971?
Ensure brevity in your answer.  0.49. What is the ratio of the Exports (in Local Currency Unit) of Afghanistan in 1966 to that in 1972?
Offer a very short reply. 0.51. What is the ratio of the Exports (in Local Currency Unit) in Bangladesh in 1966 to that in 1972?
Your response must be concise. 1.48. What is the ratio of the Exports (in Local Currency Unit) in Mexico in 1966 to that in 1972?
Your answer should be compact. 0.5. What is the ratio of the Exports (in Local Currency Unit) in Switzerland in 1966 to that in 1972?
Your response must be concise. 0.44. What is the ratio of the Exports (in Local Currency Unit) of Afghanistan in 1967 to that in 1968?
Your answer should be very brief. 0.93. What is the ratio of the Exports (in Local Currency Unit) in Bangladesh in 1967 to that in 1968?
Make the answer very short. 1.08. What is the ratio of the Exports (in Local Currency Unit) of Mexico in 1967 to that in 1968?
Make the answer very short. 0.88. What is the ratio of the Exports (in Local Currency Unit) in Switzerland in 1967 to that in 1968?
Keep it short and to the point. 0.88. What is the ratio of the Exports (in Local Currency Unit) in Afghanistan in 1967 to that in 1969?
Your answer should be compact. 0.8. What is the ratio of the Exports (in Local Currency Unit) in Bangladesh in 1967 to that in 1969?
Ensure brevity in your answer.  0.98. What is the ratio of the Exports (in Local Currency Unit) of Mexico in 1967 to that in 1969?
Your response must be concise. 0.74. What is the ratio of the Exports (in Local Currency Unit) in Switzerland in 1967 to that in 1969?
Your response must be concise. 0.77. What is the ratio of the Exports (in Local Currency Unit) in Afghanistan in 1967 to that in 1970?
Provide a short and direct response. 0.66. What is the ratio of the Exports (in Local Currency Unit) in Bangladesh in 1967 to that in 1970?
Make the answer very short. 0.9. What is the ratio of the Exports (in Local Currency Unit) in Mexico in 1967 to that in 1970?
Ensure brevity in your answer.  0.66. What is the ratio of the Exports (in Local Currency Unit) in Switzerland in 1967 to that in 1970?
Your answer should be compact. 0.56. What is the ratio of the Exports (in Local Currency Unit) of Afghanistan in 1967 to that in 1971?
Your answer should be compact. 0.57. What is the ratio of the Exports (in Local Currency Unit) in Bangladesh in 1967 to that in 1971?
Your answer should be compact. 1.23. What is the ratio of the Exports (in Local Currency Unit) in Mexico in 1967 to that in 1971?
Keep it short and to the point. 0.61. What is the ratio of the Exports (in Local Currency Unit) of Switzerland in 1967 to that in 1971?
Your answer should be very brief. 0.52. What is the ratio of the Exports (in Local Currency Unit) of Afghanistan in 1967 to that in 1972?
Your answer should be very brief. 0.48. What is the ratio of the Exports (in Local Currency Unit) in Bangladesh in 1967 to that in 1972?
Provide a succinct answer. 1.51. What is the ratio of the Exports (in Local Currency Unit) of Mexico in 1967 to that in 1972?
Provide a succinct answer. 0.5. What is the ratio of the Exports (in Local Currency Unit) in Switzerland in 1967 to that in 1972?
Provide a succinct answer. 0.47. What is the ratio of the Exports (in Local Currency Unit) in Afghanistan in 1968 to that in 1969?
Offer a very short reply. 0.86. What is the ratio of the Exports (in Local Currency Unit) in Bangladesh in 1968 to that in 1969?
Provide a short and direct response. 0.9. What is the ratio of the Exports (in Local Currency Unit) in Mexico in 1968 to that in 1969?
Provide a succinct answer. 0.84. What is the ratio of the Exports (in Local Currency Unit) in Switzerland in 1968 to that in 1969?
Offer a very short reply. 0.87. What is the ratio of the Exports (in Local Currency Unit) of Bangladesh in 1968 to that in 1970?
Your response must be concise. 0.83. What is the ratio of the Exports (in Local Currency Unit) of Mexico in 1968 to that in 1970?
Ensure brevity in your answer.  0.75. What is the ratio of the Exports (in Local Currency Unit) in Switzerland in 1968 to that in 1970?
Keep it short and to the point. 0.63. What is the ratio of the Exports (in Local Currency Unit) in Afghanistan in 1968 to that in 1971?
Provide a short and direct response. 0.61. What is the ratio of the Exports (in Local Currency Unit) of Bangladesh in 1968 to that in 1971?
Ensure brevity in your answer.  1.13. What is the ratio of the Exports (in Local Currency Unit) of Mexico in 1968 to that in 1971?
Your response must be concise. 0.69. What is the ratio of the Exports (in Local Currency Unit) in Switzerland in 1968 to that in 1971?
Make the answer very short. 0.59. What is the ratio of the Exports (in Local Currency Unit) of Afghanistan in 1968 to that in 1972?
Give a very brief answer. 0.52. What is the ratio of the Exports (in Local Currency Unit) in Bangladesh in 1968 to that in 1972?
Your answer should be very brief. 1.4. What is the ratio of the Exports (in Local Currency Unit) of Mexico in 1968 to that in 1972?
Your answer should be compact. 0.57. What is the ratio of the Exports (in Local Currency Unit) in Switzerland in 1968 to that in 1972?
Your answer should be compact. 0.53. What is the ratio of the Exports (in Local Currency Unit) in Afghanistan in 1969 to that in 1970?
Offer a terse response. 0.83. What is the ratio of the Exports (in Local Currency Unit) of Bangladesh in 1969 to that in 1970?
Keep it short and to the point. 0.92. What is the ratio of the Exports (in Local Currency Unit) of Mexico in 1969 to that in 1970?
Your response must be concise. 0.89. What is the ratio of the Exports (in Local Currency Unit) of Switzerland in 1969 to that in 1970?
Your answer should be compact. 0.73. What is the ratio of the Exports (in Local Currency Unit) in Afghanistan in 1969 to that in 1971?
Give a very brief answer. 0.71. What is the ratio of the Exports (in Local Currency Unit) in Bangladesh in 1969 to that in 1971?
Offer a very short reply. 1.25. What is the ratio of the Exports (in Local Currency Unit) in Mexico in 1969 to that in 1971?
Your answer should be compact. 0.82. What is the ratio of the Exports (in Local Currency Unit) in Switzerland in 1969 to that in 1971?
Your answer should be very brief. 0.68. What is the ratio of the Exports (in Local Currency Unit) in Afghanistan in 1969 to that in 1972?
Ensure brevity in your answer.  0.6. What is the ratio of the Exports (in Local Currency Unit) in Bangladesh in 1969 to that in 1972?
Provide a succinct answer. 1.55. What is the ratio of the Exports (in Local Currency Unit) of Mexico in 1969 to that in 1972?
Make the answer very short. 0.67. What is the ratio of the Exports (in Local Currency Unit) of Switzerland in 1969 to that in 1972?
Provide a short and direct response. 0.61. What is the ratio of the Exports (in Local Currency Unit) of Afghanistan in 1970 to that in 1971?
Offer a very short reply. 0.86. What is the ratio of the Exports (in Local Currency Unit) of Bangladesh in 1970 to that in 1971?
Provide a short and direct response. 1.36. What is the ratio of the Exports (in Local Currency Unit) in Mexico in 1970 to that in 1971?
Give a very brief answer. 0.92. What is the ratio of the Exports (in Local Currency Unit) of Switzerland in 1970 to that in 1971?
Provide a short and direct response. 0.93. What is the ratio of the Exports (in Local Currency Unit) in Afghanistan in 1970 to that in 1972?
Ensure brevity in your answer.  0.73. What is the ratio of the Exports (in Local Currency Unit) in Bangladesh in 1970 to that in 1972?
Offer a terse response. 1.68. What is the ratio of the Exports (in Local Currency Unit) of Mexico in 1970 to that in 1972?
Your answer should be very brief. 0.76. What is the ratio of the Exports (in Local Currency Unit) in Switzerland in 1970 to that in 1972?
Keep it short and to the point. 0.83. What is the ratio of the Exports (in Local Currency Unit) of Afghanistan in 1971 to that in 1972?
Offer a very short reply. 0.85. What is the ratio of the Exports (in Local Currency Unit) in Bangladesh in 1971 to that in 1972?
Offer a terse response. 1.23. What is the ratio of the Exports (in Local Currency Unit) of Mexico in 1971 to that in 1972?
Your answer should be very brief. 0.82. What is the ratio of the Exports (in Local Currency Unit) of Switzerland in 1971 to that in 1972?
Your answer should be very brief. 0.9. What is the difference between the highest and the second highest Exports (in Local Currency Unit) of Afghanistan?
Provide a succinct answer. 1.60e+09. What is the difference between the highest and the second highest Exports (in Local Currency Unit) of Bangladesh?
Offer a very short reply. 2.76e+08. What is the difference between the highest and the second highest Exports (in Local Currency Unit) in Mexico?
Keep it short and to the point. 8.10e+06. What is the difference between the highest and the second highest Exports (in Local Currency Unit) in Switzerland?
Offer a very short reply. 4.81e+09. What is the difference between the highest and the lowest Exports (in Local Currency Unit) of Afghanistan?
Your answer should be compact. 5.50e+09. What is the difference between the highest and the lowest Exports (in Local Currency Unit) of Bangladesh?
Your answer should be very brief. 1.45e+09. What is the difference between the highest and the lowest Exports (in Local Currency Unit) in Mexico?
Make the answer very short. 2.28e+07. What is the difference between the highest and the lowest Exports (in Local Currency Unit) of Switzerland?
Give a very brief answer. 2.61e+1. 